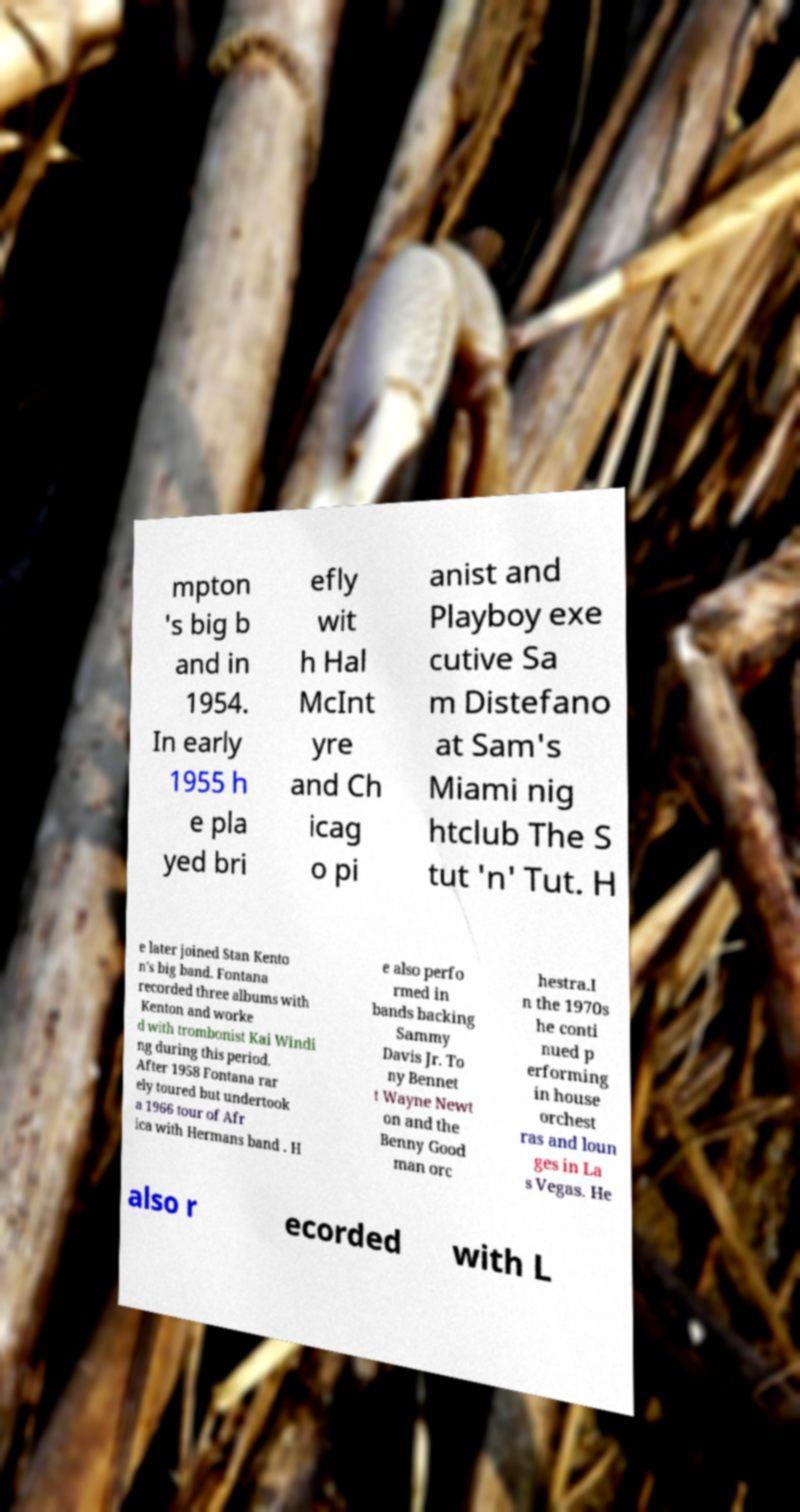Please read and relay the text visible in this image. What does it say? mpton 's big b and in 1954. In early 1955 h e pla yed bri efly wit h Hal McInt yre and Ch icag o pi anist and Playboy exe cutive Sa m Distefano at Sam's Miami nig htclub The S tut 'n' Tut. H e later joined Stan Kento n's big band. Fontana recorded three albums with Kenton and worke d with trombonist Kai Windi ng during this period. After 1958 Fontana rar ely toured but undertook a 1966 tour of Afr ica with Hermans band . H e also perfo rmed in bands backing Sammy Davis Jr. To ny Bennet t Wayne Newt on and the Benny Good man orc hestra.I n the 1970s he conti nued p erforming in house orchest ras and loun ges in La s Vegas. He also r ecorded with L 